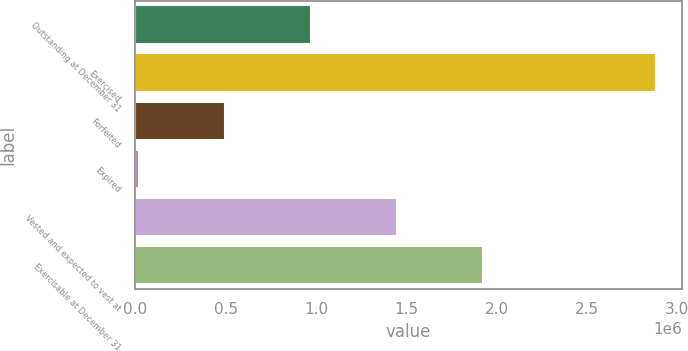Convert chart. <chart><loc_0><loc_0><loc_500><loc_500><bar_chart><fcel>Outstanding at December 31<fcel>Exercised<fcel>Forfeited<fcel>Expired<fcel>Vested and expected to vest at<fcel>Exercisable at December 31<nl><fcel>972879<fcel>2.88264e+06<fcel>495438<fcel>17997<fcel>1.45032e+06<fcel>1.92776e+06<nl></chart> 